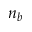Convert formula to latex. <formula><loc_0><loc_0><loc_500><loc_500>n _ { b }</formula> 